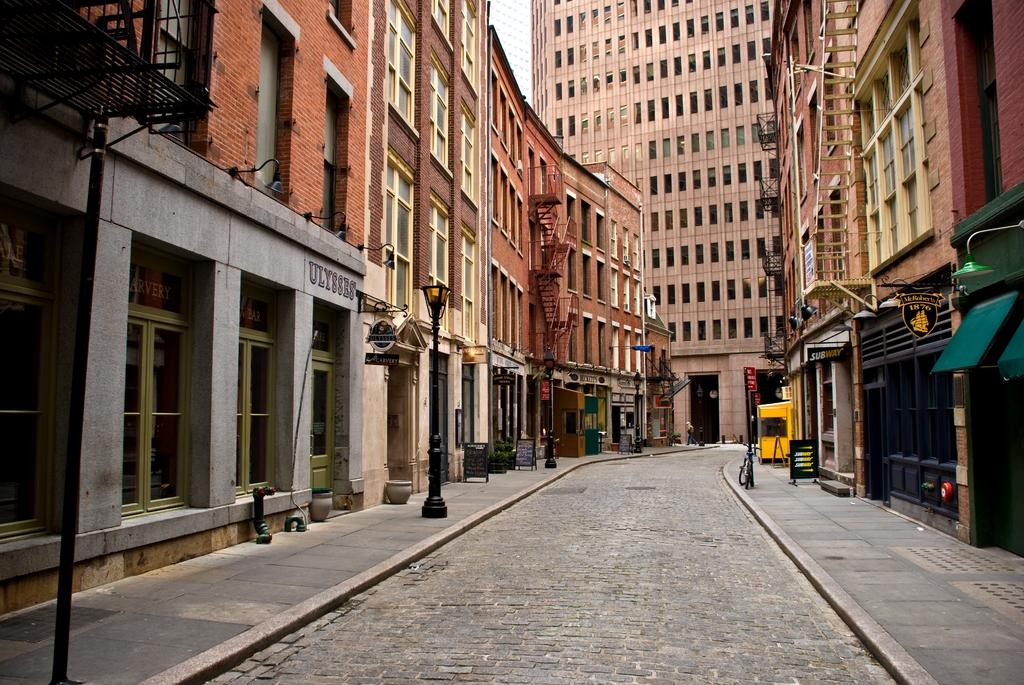What type of structures can be seen in the image? There are buildings in the image. What else is present in the image besides buildings? There are poles in the image. What can be seen beneath the buildings and poles? The ground is visible in the image. Are there any objects placed on the ground? Yes, there are objects on the ground. What can be observed in the top left corner of the image? There are black colored objects in the top left corner of the image. What type of fuel is being used by the rock in the image? There is no rock or fuel present in the image. How does the throat of the person in the image look? There is no person or throat visible in the image. 